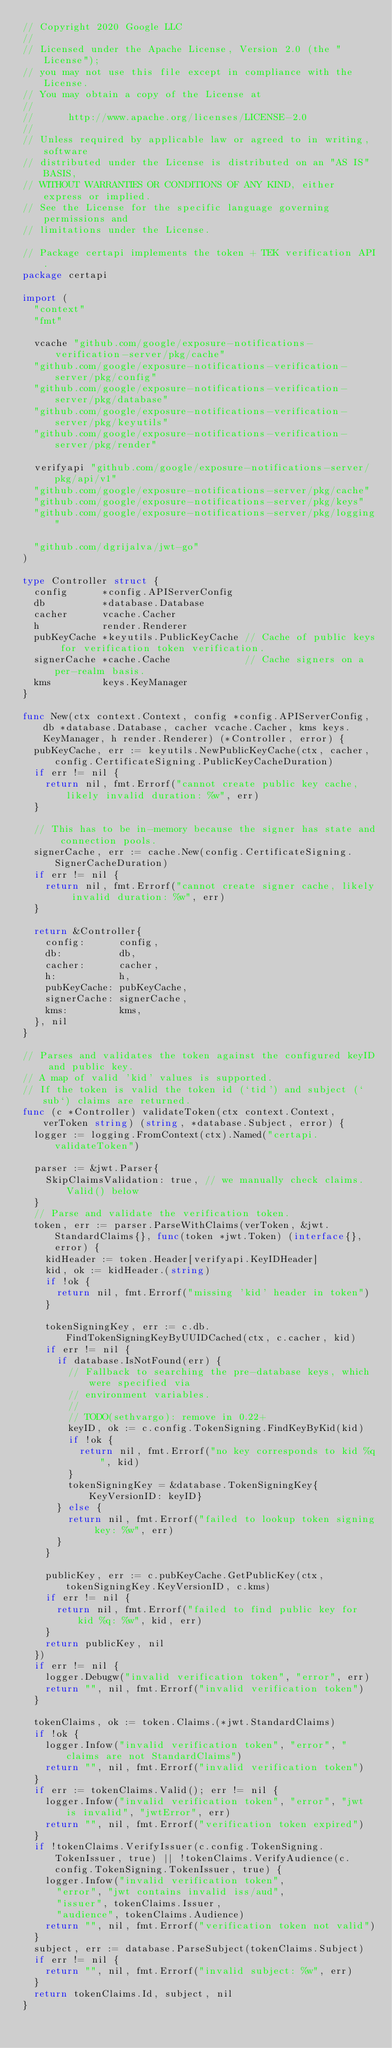<code> <loc_0><loc_0><loc_500><loc_500><_Go_>// Copyright 2020 Google LLC
//
// Licensed under the Apache License, Version 2.0 (the "License");
// you may not use this file except in compliance with the License.
// You may obtain a copy of the License at
//
//      http://www.apache.org/licenses/LICENSE-2.0
//
// Unless required by applicable law or agreed to in writing, software
// distributed under the License is distributed on an "AS IS" BASIS,
// WITHOUT WARRANTIES OR CONDITIONS OF ANY KIND, either express or implied.
// See the License for the specific language governing permissions and
// limitations under the License.

// Package certapi implements the token + TEK verification API.
package certapi

import (
	"context"
	"fmt"

	vcache "github.com/google/exposure-notifications-verification-server/pkg/cache"
	"github.com/google/exposure-notifications-verification-server/pkg/config"
	"github.com/google/exposure-notifications-verification-server/pkg/database"
	"github.com/google/exposure-notifications-verification-server/pkg/keyutils"
	"github.com/google/exposure-notifications-verification-server/pkg/render"

	verifyapi "github.com/google/exposure-notifications-server/pkg/api/v1"
	"github.com/google/exposure-notifications-server/pkg/cache"
	"github.com/google/exposure-notifications-server/pkg/keys"
	"github.com/google/exposure-notifications-server/pkg/logging"

	"github.com/dgrijalva/jwt-go"
)

type Controller struct {
	config      *config.APIServerConfig
	db          *database.Database
	cacher      vcache.Cacher
	h           render.Renderer
	pubKeyCache *keyutils.PublicKeyCache // Cache of public keys for verification token verification.
	signerCache *cache.Cache             // Cache signers on a per-realm basis.
	kms         keys.KeyManager
}

func New(ctx context.Context, config *config.APIServerConfig, db *database.Database, cacher vcache.Cacher, kms keys.KeyManager, h render.Renderer) (*Controller, error) {
	pubKeyCache, err := keyutils.NewPublicKeyCache(ctx, cacher, config.CertificateSigning.PublicKeyCacheDuration)
	if err != nil {
		return nil, fmt.Errorf("cannot create public key cache, likely invalid duration: %w", err)
	}

	// This has to be in-memory because the signer has state and connection pools.
	signerCache, err := cache.New(config.CertificateSigning.SignerCacheDuration)
	if err != nil {
		return nil, fmt.Errorf("cannot create signer cache, likely invalid duration: %w", err)
	}

	return &Controller{
		config:      config,
		db:          db,
		cacher:      cacher,
		h:           h,
		pubKeyCache: pubKeyCache,
		signerCache: signerCache,
		kms:         kms,
	}, nil
}

// Parses and validates the token against the configured keyID and public key.
// A map of valid 'kid' values is supported.
// If the token is valid the token id (`tid') and subject (`sub`) claims are returned.
func (c *Controller) validateToken(ctx context.Context, verToken string) (string, *database.Subject, error) {
	logger := logging.FromContext(ctx).Named("certapi.validateToken")

	parser := &jwt.Parser{
		SkipClaimsValidation: true, // we manually check claims.Valid() below
	}
	// Parse and validate the verification token.
	token, err := parser.ParseWithClaims(verToken, &jwt.StandardClaims{}, func(token *jwt.Token) (interface{}, error) {
		kidHeader := token.Header[verifyapi.KeyIDHeader]
		kid, ok := kidHeader.(string)
		if !ok {
			return nil, fmt.Errorf("missing 'kid' header in token")
		}

		tokenSigningKey, err := c.db.FindTokenSigningKeyByUUIDCached(ctx, c.cacher, kid)
		if err != nil {
			if database.IsNotFound(err) {
				// Fallback to searching the pre-database keys, which were specified via
				// environment variables.
				//
				// TODO(sethvargo): remove in 0.22+
				keyID, ok := c.config.TokenSigning.FindKeyByKid(kid)
				if !ok {
					return nil, fmt.Errorf("no key corresponds to kid %q", kid)
				}
				tokenSigningKey = &database.TokenSigningKey{KeyVersionID: keyID}
			} else {
				return nil, fmt.Errorf("failed to lookup token signing key: %w", err)
			}
		}

		publicKey, err := c.pubKeyCache.GetPublicKey(ctx, tokenSigningKey.KeyVersionID, c.kms)
		if err != nil {
			return nil, fmt.Errorf("failed to find public key for kid %q: %w", kid, err)
		}
		return publicKey, nil
	})
	if err != nil {
		logger.Debugw("invalid verification token", "error", err)
		return "", nil, fmt.Errorf("invalid verification token")
	}

	tokenClaims, ok := token.Claims.(*jwt.StandardClaims)
	if !ok {
		logger.Infow("invalid verification token", "error", "claims are not StandardClaims")
		return "", nil, fmt.Errorf("invalid verification token")
	}
	if err := tokenClaims.Valid(); err != nil {
		logger.Infow("invalid verification token", "error", "jwt is invalid", "jwtError", err)
		return "", nil, fmt.Errorf("verification token expired")
	}
	if !tokenClaims.VerifyIssuer(c.config.TokenSigning.TokenIssuer, true) || !tokenClaims.VerifyAudience(c.config.TokenSigning.TokenIssuer, true) {
		logger.Infow("invalid verification token",
			"error", "jwt contains invalid iss/aud",
			"issuer", tokenClaims.Issuer,
			"audience", tokenClaims.Audience)
		return "", nil, fmt.Errorf("verification token not valid")
	}
	subject, err := database.ParseSubject(tokenClaims.Subject)
	if err != nil {
		return "", nil, fmt.Errorf("invalid subject: %w", err)
	}
	return tokenClaims.Id, subject, nil
}
</code> 